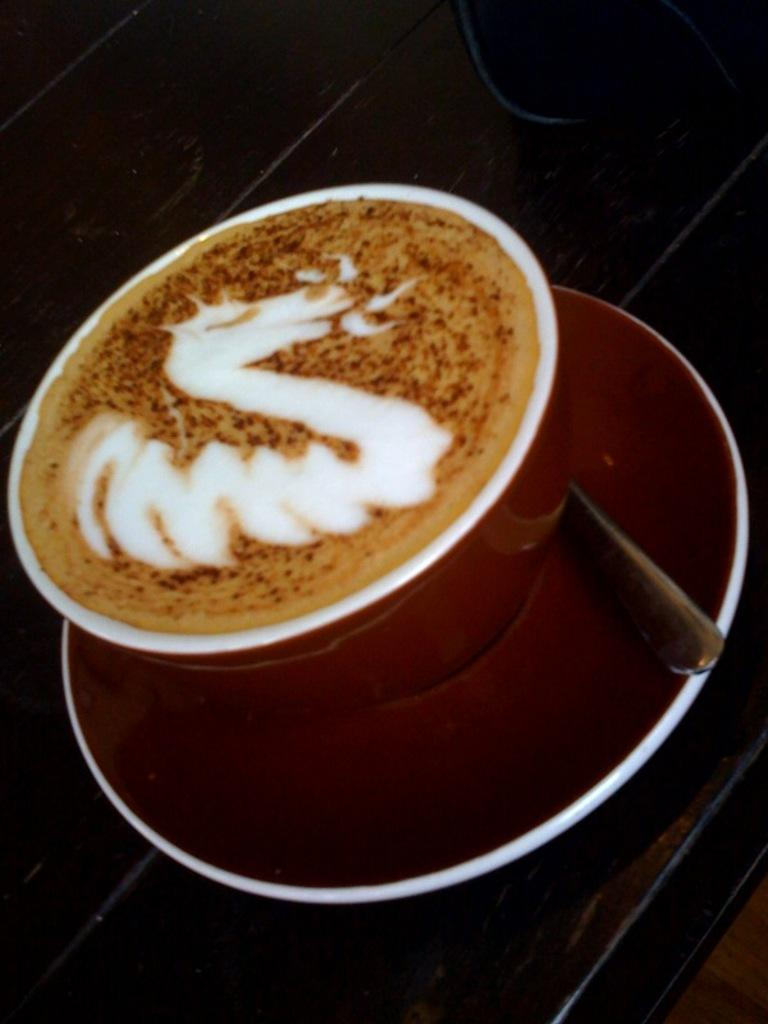What is present in the image along with the cup? There is a saucer and a spoon in the image. Where is the saucer located in relation to the cup? The saucer is placed on a surface. What is the purpose of the spoon in the image? The spoon is likely used for stirring or consuming the drink in the cup. What is contained within the cup? There is a drink in the cup. What is the value of the nail in the image? There is no nail present in the image, so it is not possible to determine its value. 